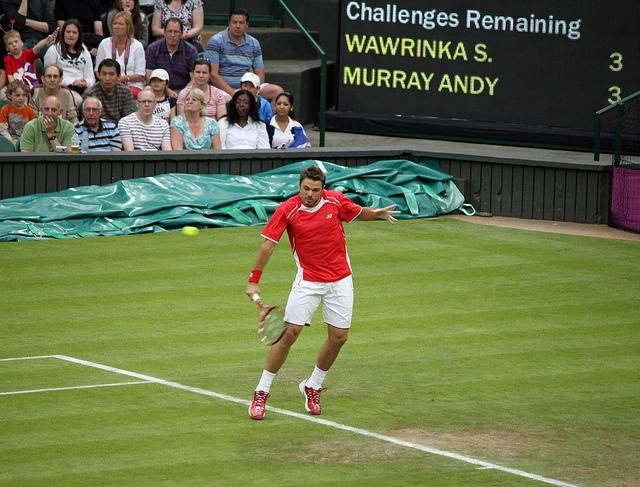What type of sign is shown? Please explain your reasoning. scoreboard. As indicated by the numbers and names. 